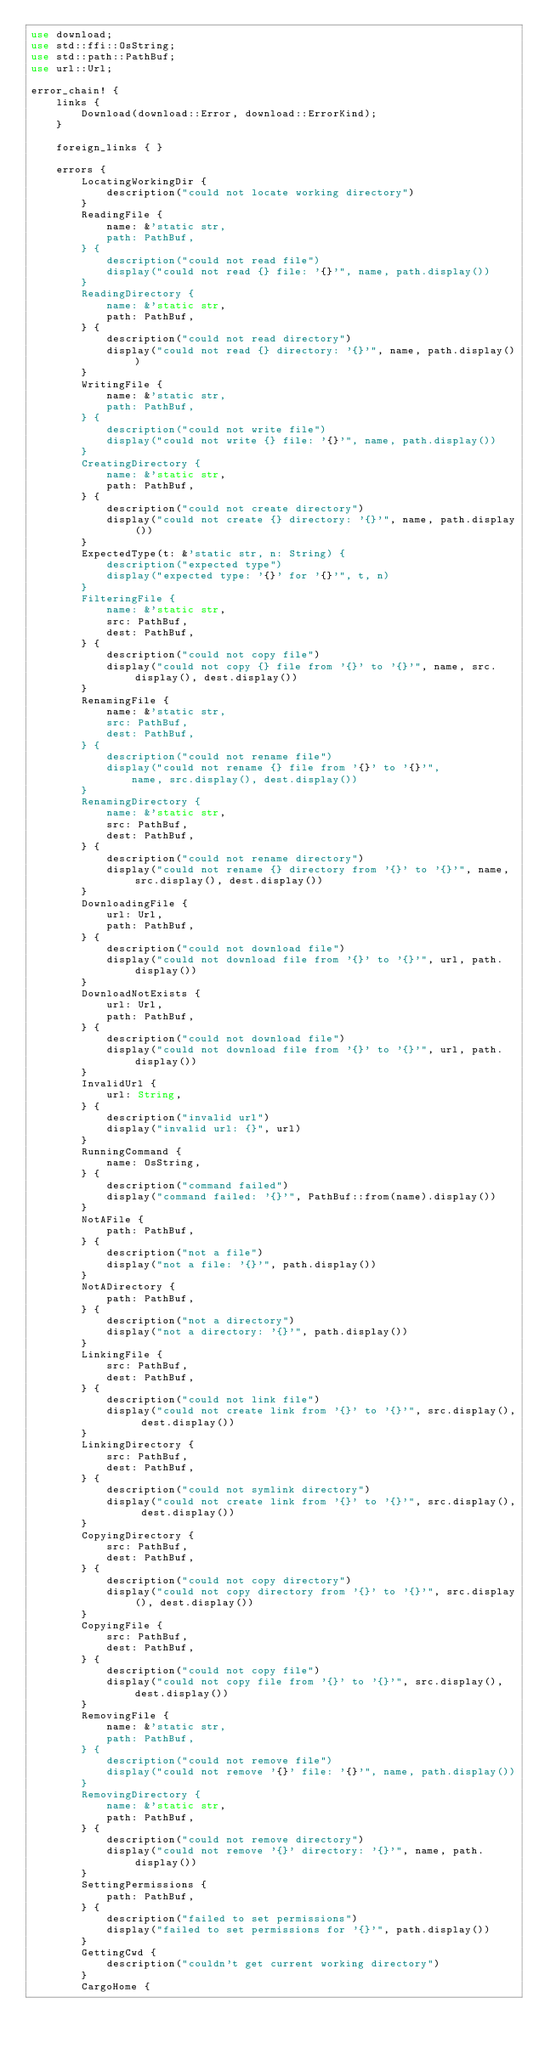Convert code to text. <code><loc_0><loc_0><loc_500><loc_500><_Rust_>use download;
use std::ffi::OsString;
use std::path::PathBuf;
use url::Url;

error_chain! {
    links {
        Download(download::Error, download::ErrorKind);
    }

    foreign_links { }

    errors {
        LocatingWorkingDir {
            description("could not locate working directory")
        }
        ReadingFile {
            name: &'static str,
            path: PathBuf,
        } {
            description("could not read file")
            display("could not read {} file: '{}'", name, path.display())
        }
        ReadingDirectory {
            name: &'static str,
            path: PathBuf,
        } {
            description("could not read directory")
            display("could not read {} directory: '{}'", name, path.display())
        }
        WritingFile {
            name: &'static str,
            path: PathBuf,
        } {
            description("could not write file")
            display("could not write {} file: '{}'", name, path.display())
        }
        CreatingDirectory {
            name: &'static str,
            path: PathBuf,
        } {
            description("could not create directory")
            display("could not create {} directory: '{}'", name, path.display())
        }
        ExpectedType(t: &'static str, n: String) {
            description("expected type")
            display("expected type: '{}' for '{}'", t, n)
        }
        FilteringFile {
            name: &'static str,
            src: PathBuf,
            dest: PathBuf,
        } {
            description("could not copy file")
            display("could not copy {} file from '{}' to '{}'", name, src.display(), dest.display())
        }
        RenamingFile {
            name: &'static str,
            src: PathBuf,
            dest: PathBuf,
        } {
            description("could not rename file")
            display("could not rename {} file from '{}' to '{}'",
                name, src.display(), dest.display())
        }
        RenamingDirectory {
            name: &'static str,
            src: PathBuf,
            dest: PathBuf,
        } {
            description("could not rename directory")
            display("could not rename {} directory from '{}' to '{}'", name, src.display(), dest.display())
        }
        DownloadingFile {
            url: Url,
            path: PathBuf,
        } {
            description("could not download file")
            display("could not download file from '{}' to '{}'", url, path.display())
        }
        DownloadNotExists {
            url: Url,
            path: PathBuf,
        } {
            description("could not download file")
            display("could not download file from '{}' to '{}'", url, path.display())
        }
        InvalidUrl {
            url: String,
        } {
            description("invalid url")
            display("invalid url: {}", url)
        }
        RunningCommand {
            name: OsString,
        } {
            description("command failed")
            display("command failed: '{}'", PathBuf::from(name).display())
        }
        NotAFile {
            path: PathBuf,
        } {
            description("not a file")
            display("not a file: '{}'", path.display())
        }
        NotADirectory {
            path: PathBuf,
        } {
            description("not a directory")
            display("not a directory: '{}'", path.display())
        }
        LinkingFile {
            src: PathBuf,
            dest: PathBuf,
        } {
            description("could not link file")
            display("could not create link from '{}' to '{}'", src.display(), dest.display())
        }
        LinkingDirectory {
            src: PathBuf,
            dest: PathBuf,
        } {
            description("could not symlink directory")
            display("could not create link from '{}' to '{}'", src.display(), dest.display())
        }
        CopyingDirectory {
            src: PathBuf,
            dest: PathBuf,
        } {
            description("could not copy directory")
            display("could not copy directory from '{}' to '{}'", src.display(), dest.display())
        }
        CopyingFile {
            src: PathBuf,
            dest: PathBuf,
        } {
            description("could not copy file")
            display("could not copy file from '{}' to '{}'", src.display(), dest.display())
        }
        RemovingFile {
            name: &'static str,
            path: PathBuf,
        } {
            description("could not remove file")
            display("could not remove '{}' file: '{}'", name, path.display())
        }
        RemovingDirectory {
            name: &'static str,
            path: PathBuf,
        } {
            description("could not remove directory")
            display("could not remove '{}' directory: '{}'", name, path.display())
        }
        SettingPermissions {
            path: PathBuf,
        } {
            description("failed to set permissions")
            display("failed to set permissions for '{}'", path.display())
        }
        GettingCwd {
            description("couldn't get current working directory")
        }
        CargoHome {</code> 